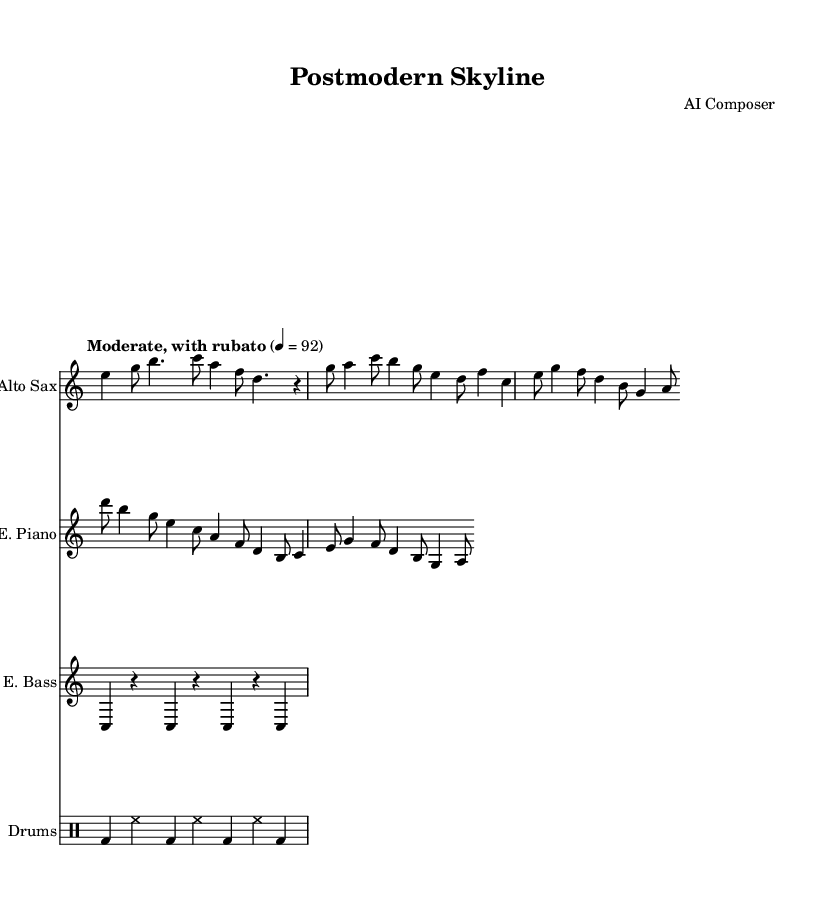What is the time signature of this piece? The time signature is indicated at the beginning of the piece and shows a 7/4. This means there are seven beats in a measure, and the quarter note gets the beat.
Answer: 7/4 What is the tempo marking given for the music? The tempo marking provided in the score specifies "Moderate, with rubato" and indicates a metronome marking of 92 beats per minute. This means the piece should be played at a moderate speed with flexible timing.
Answer: Moderate, with rubato Which instruments are featured in this composition? The instruments are listed in the score, specifically: Alto Sax, Electric Piano, Electric Bass, and Drums.
Answer: Alto Sax, Electric Piano, Electric Bass, Drums How many measures are in the Intro section? The Intro section consists of one measure, as indicated by the notation for that part of the piece. Each group of notes is structured to fit within a single measure in the score.
Answer: 1 What is unique about the bass rhythm pattern? The bass rhythm pattern displays a syncopated design where the notes often follow a pattern of rests interspersed with the note 'C', creating a driving rhythmic feel. This follows a repetitive structure with rests.
Answer: Syncopated What type of harmony is suggested throughout the piece? The harmony in this composition suggests modal influences typically found in jazz fusion, as it lacks traditional functional harmony and embraces more open, adventurous structures inherent in postmodern influences.
Answer: Modal Describe the rhythmic feel of the drums. The drum part features a simple and steady pattern that alternates between bass drum hits on the downbeats and hi-hat on the upbeat, creating a consistent driving rhythm that complements the other instruments.
Answer: Steady 